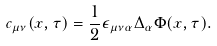Convert formula to latex. <formula><loc_0><loc_0><loc_500><loc_500>c _ { \mu \nu } ( x , \tau ) = \frac { 1 } { 2 } \epsilon _ { \mu \nu \alpha } \Delta _ { \alpha } \Phi ( x , \tau ) .</formula> 